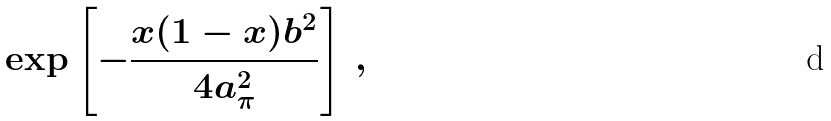<formula> <loc_0><loc_0><loc_500><loc_500>\exp \left [ - \frac { x ( 1 - x ) b ^ { 2 } } { 4 a _ { \pi } ^ { 2 } } \right ] \, ,</formula> 